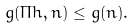Convert formula to latex. <formula><loc_0><loc_0><loc_500><loc_500>g ( \Pi h , n ) \leq g ( n ) .</formula> 